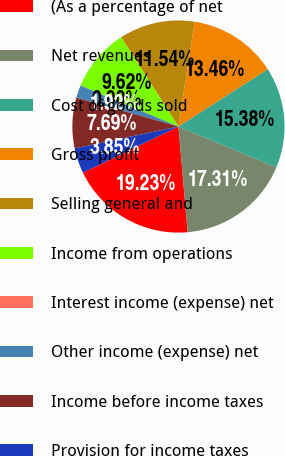Convert chart to OTSL. <chart><loc_0><loc_0><loc_500><loc_500><pie_chart><fcel>(As a percentage of net<fcel>Net revenues<fcel>Cost of goods sold<fcel>Gross profit<fcel>Selling general and<fcel>Income from operations<fcel>Interest income (expense) net<fcel>Other income (expense) net<fcel>Income before income taxes<fcel>Provision for income taxes<nl><fcel>19.23%<fcel>17.31%<fcel>15.38%<fcel>13.46%<fcel>11.54%<fcel>9.62%<fcel>0.0%<fcel>1.92%<fcel>7.69%<fcel>3.85%<nl></chart> 